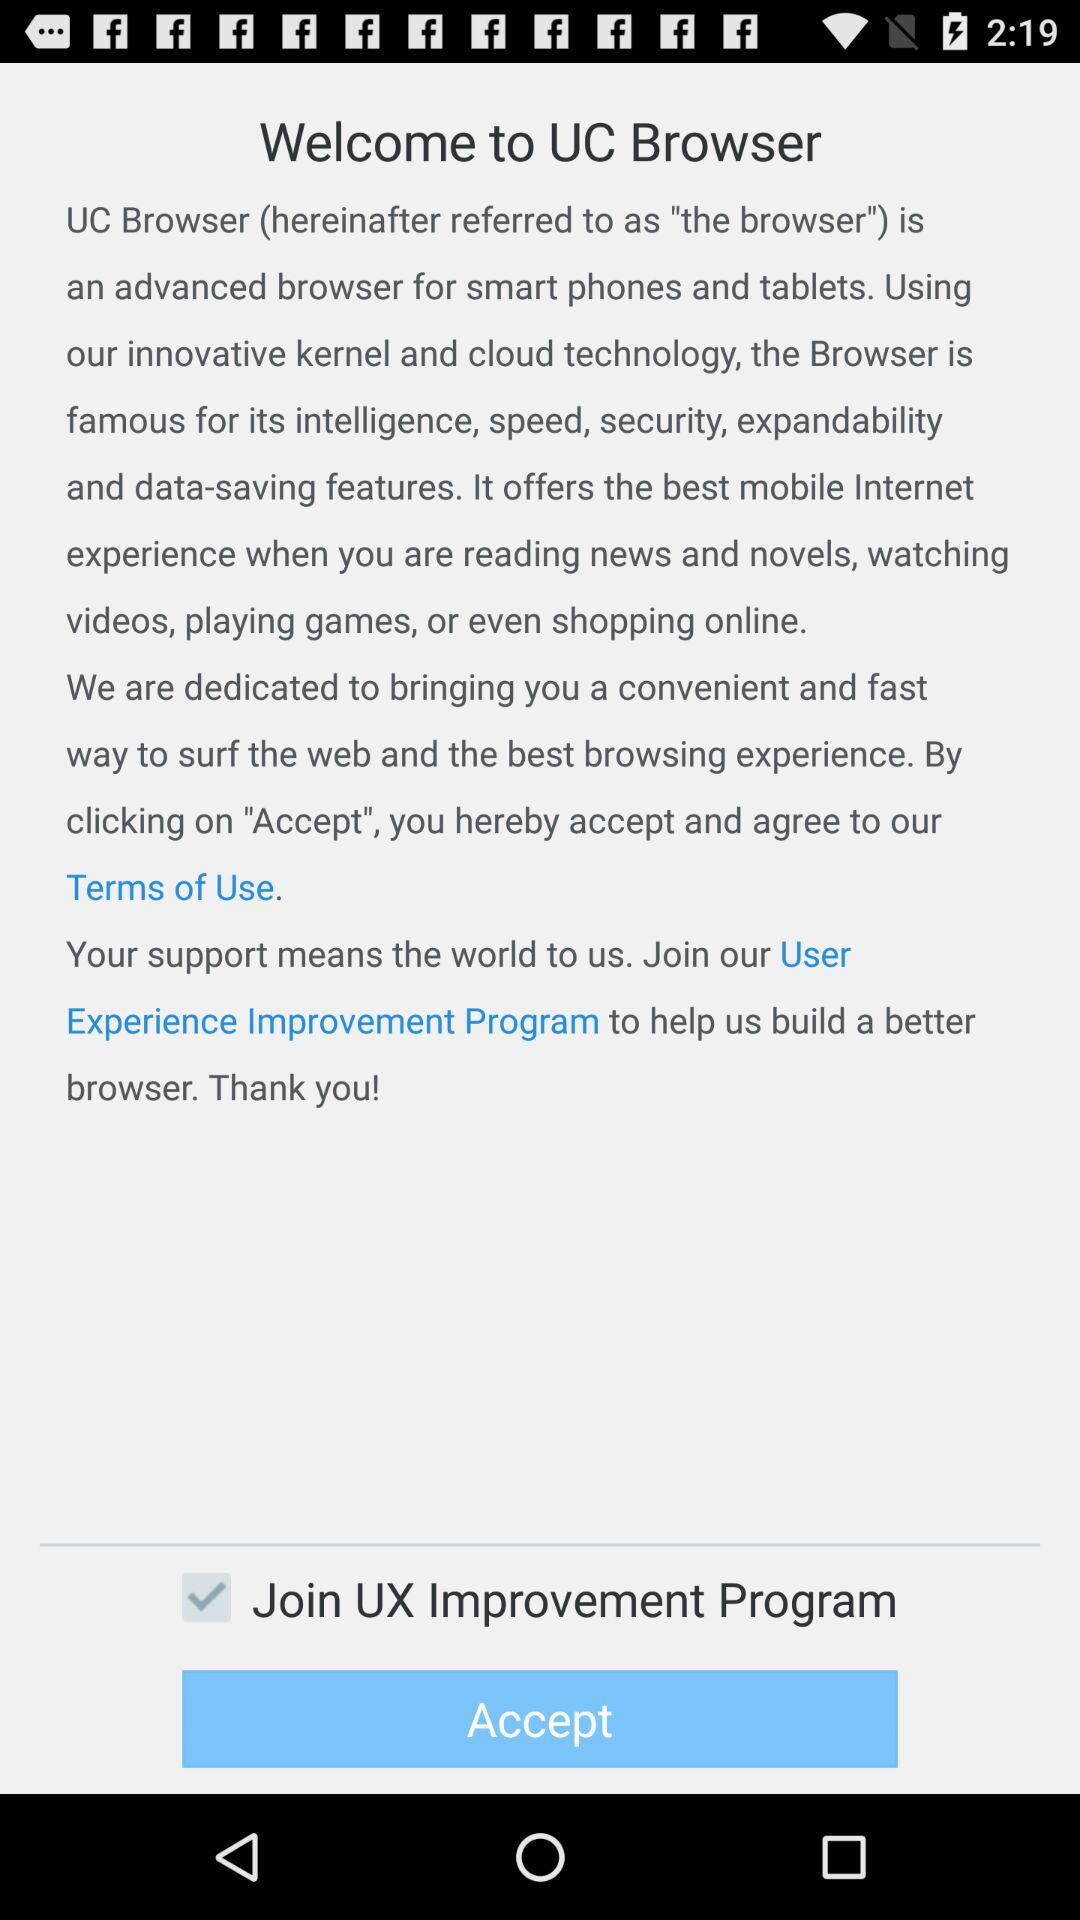Which technology is used for the "UC Browser"? For the "UC Browser", the innovative kernel and cloud technology are used. 